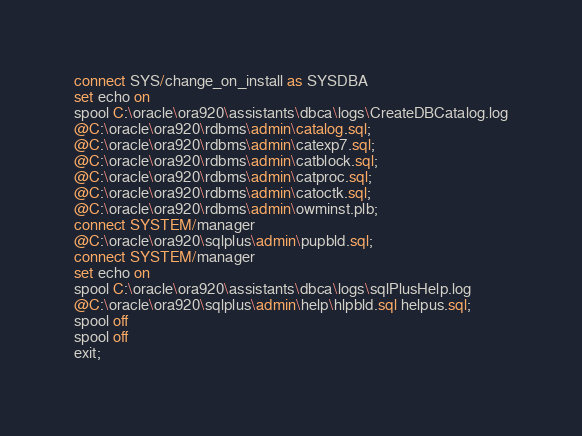<code> <loc_0><loc_0><loc_500><loc_500><_SQL_>connect SYS/change_on_install as SYSDBA
set echo on
spool C:\oracle\ora920\assistants\dbca\logs\CreateDBCatalog.log
@C:\oracle\ora920\rdbms\admin\catalog.sql;
@C:\oracle\ora920\rdbms\admin\catexp7.sql;
@C:\oracle\ora920\rdbms\admin\catblock.sql;
@C:\oracle\ora920\rdbms\admin\catproc.sql;
@C:\oracle\ora920\rdbms\admin\catoctk.sql;
@C:\oracle\ora920\rdbms\admin\owminst.plb;
connect SYSTEM/manager
@C:\oracle\ora920\sqlplus\admin\pupbld.sql;
connect SYSTEM/manager
set echo on
spool C:\oracle\ora920\assistants\dbca\logs\sqlPlusHelp.log
@C:\oracle\ora920\sqlplus\admin\help\hlpbld.sql helpus.sql;
spool off
spool off
exit;
</code> 